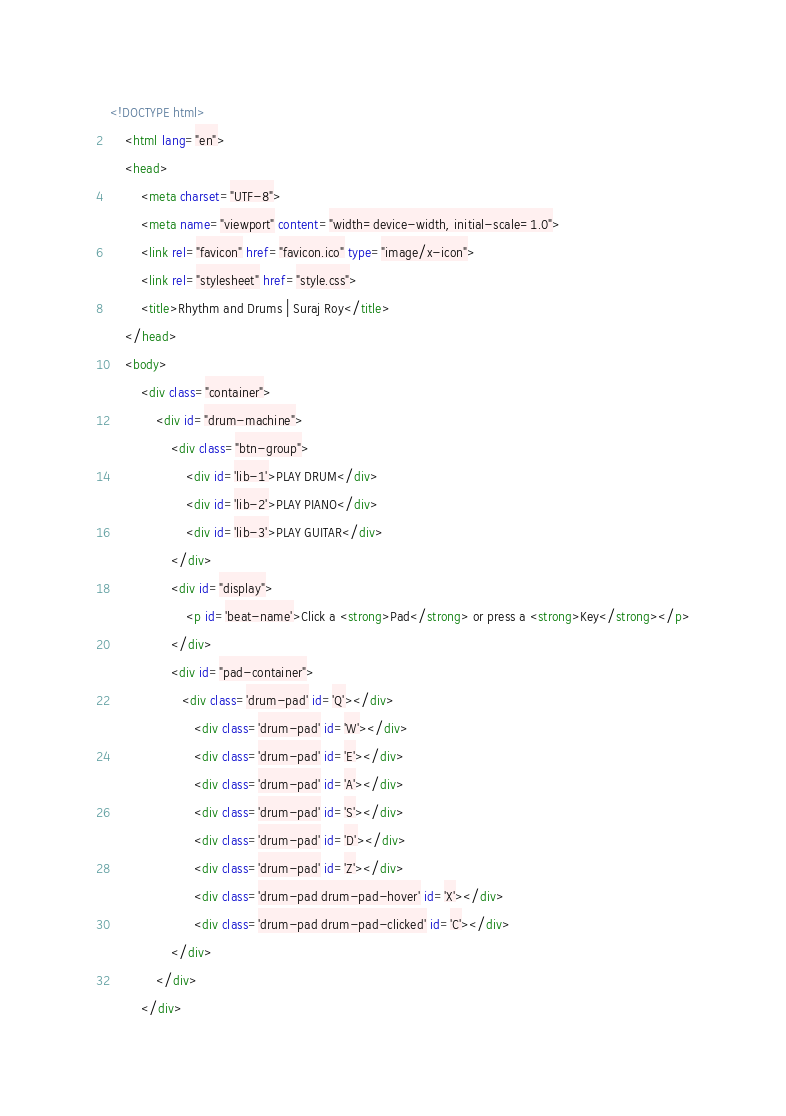Convert code to text. <code><loc_0><loc_0><loc_500><loc_500><_HTML_><!DOCTYPE html>
    <html lang="en">
    <head>
        <meta charset="UTF-8">
        <meta name="viewport" content="width=device-width, initial-scale=1.0">
        <link rel="favicon" href="favicon.ico" type="image/x-icon">
        <link rel="stylesheet" href="style.css">
        <title>Rhythm and Drums | Suraj Roy</title>
    </head>
    <body>
        <div class="container">
            <div id="drum-machine">
                <div class="btn-group">
                    <div id='lib-1'>PLAY DRUM</div>
                    <div id='lib-2'>PLAY PIANO</div>
                    <div id='lib-3'>PLAY GUITAR</div>
                </div>
                <div id="display">
                    <p id='beat-name'>Click a <strong>Pad</strong> or press a <strong>Key</strong></p>
                </div>
                <div id="pad-container">
                   <div class='drum-pad' id='Q'></div>
                      <div class='drum-pad' id='W'></div>
                      <div class='drum-pad' id='E'></div>
                      <div class='drum-pad' id='A'></div>
                      <div class='drum-pad' id='S'></div>
                      <div class='drum-pad' id='D'></div>
                      <div class='drum-pad' id='Z'></div>
                      <div class='drum-pad drum-pad-hover' id='X'></div>
                      <div class='drum-pad drum-pad-clicked' id='C'></div>
                </div>
            </div>
        </div></code> 